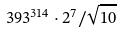<formula> <loc_0><loc_0><loc_500><loc_500>3 9 3 ^ { 3 1 4 } \cdot 2 ^ { 7 } / \sqrt { 1 0 }</formula> 